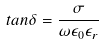Convert formula to latex. <formula><loc_0><loc_0><loc_500><loc_500>t a n \delta = \frac { \sigma } { \omega \epsilon _ { 0 } \epsilon _ { r } }</formula> 